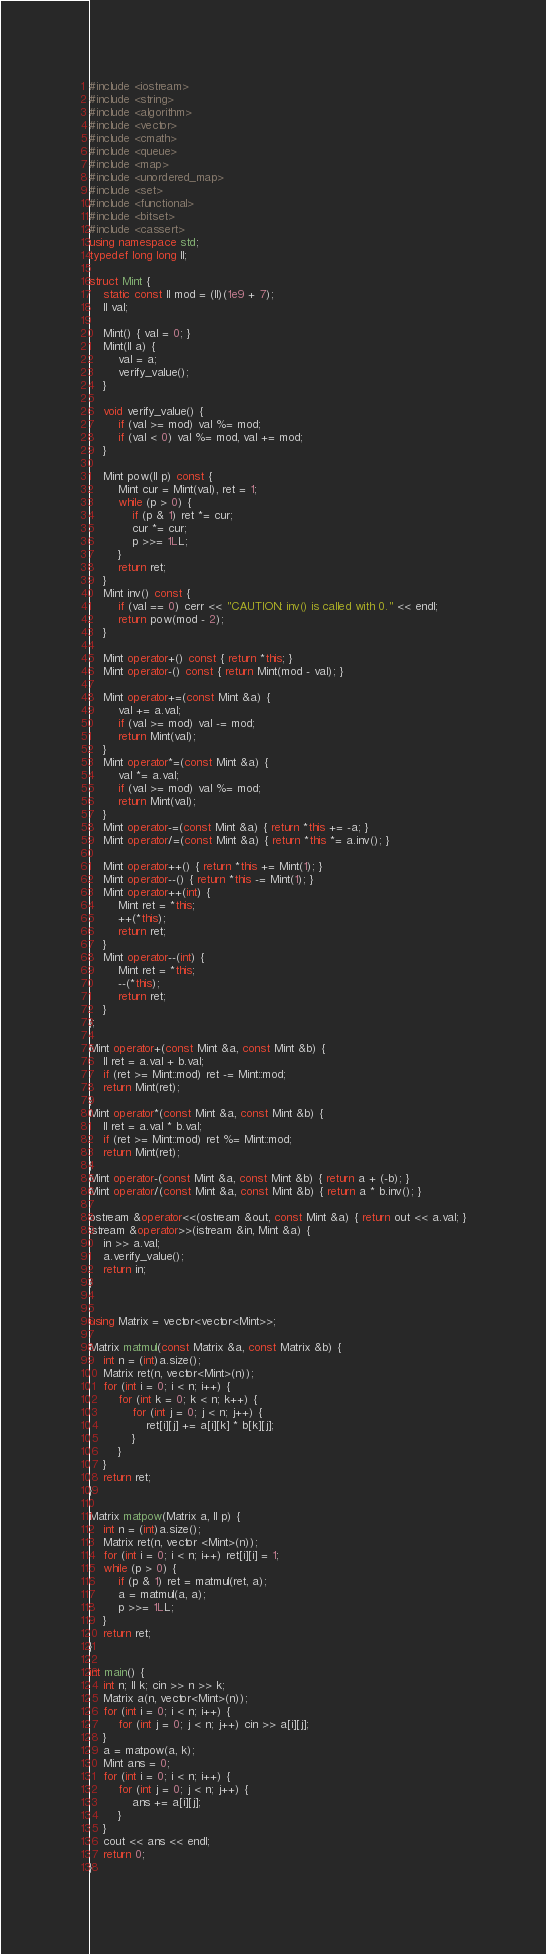Convert code to text. <code><loc_0><loc_0><loc_500><loc_500><_C++_>#include <iostream>
#include <string>
#include <algorithm>
#include <vector>
#include <cmath>
#include <queue>
#include <map>
#include <unordered_map>
#include <set>
#include <functional>
#include <bitset>
#include <cassert>
using namespace std;
typedef long long ll;

struct Mint {
	static const ll mod = (ll)(1e9 + 7);	
	ll val;

	Mint() { val = 0; }
	Mint(ll a) {
		val = a;
		verify_value();
	}

	void verify_value() {
		if (val >= mod) val %= mod;
		if (val < 0) val %= mod, val += mod;
	}

	Mint pow(ll p) const {
		Mint cur = Mint(val), ret = 1;
		while (p > 0) {
			if (p & 1) ret *= cur;
			cur *= cur;
			p >>= 1LL;
		}
		return ret;
	}
	Mint inv() const {
		if (val == 0) cerr << "CAUTION: inv() is called with 0." << endl;
		return pow(mod - 2); 
	}

	Mint operator+() const { return *this; }
	Mint operator-() const { return Mint(mod - val); }

	Mint operator+=(const Mint &a) {
		val += a.val;
		if (val >= mod) val -= mod;
		return Mint(val);
	}
	Mint operator*=(const Mint &a) {
		val *= a.val;
		if (val >= mod) val %= mod;
		return Mint(val);
	}
	Mint operator-=(const Mint &a) { return *this += -a; }
	Mint operator/=(const Mint &a) { return *this *= a.inv(); }

	Mint operator++() { return *this += Mint(1); }
	Mint operator--() { return *this -= Mint(1); }
	Mint operator++(int) {
		Mint ret = *this;
		++(*this);
		return ret;
	}
	Mint operator--(int) {
		Mint ret = *this;
		--(*this);
		return ret;
	}
};

Mint operator+(const Mint &a, const Mint &b) {
	ll ret = a.val + b.val;
	if (ret >= Mint::mod) ret -= Mint::mod;
	return Mint(ret);
}
Mint operator*(const Mint &a, const Mint &b) {
	ll ret = a.val * b.val;
	if (ret >= Mint::mod) ret %= Mint::mod;
	return Mint(ret);
}
Mint operator-(const Mint &a, const Mint &b) { return a + (-b); }
Mint operator/(const Mint &a, const Mint &b) { return a * b.inv(); }

ostream &operator<<(ostream &out, const Mint &a) { return out << a.val; }
istream &operator>>(istream &in, Mint &a) {
	in >> a.val;
	a.verify_value();
	return in;
}


using Matrix = vector<vector<Mint>>;

Matrix matmul(const Matrix &a, const Matrix &b) {
	int n = (int)a.size();
	Matrix ret(n, vector<Mint>(n));
	for (int i = 0; i < n; i++) {
		for (int k = 0; k < n; k++) {
			for (int j = 0; j < n; j++) {
				ret[i][j] += a[i][k] * b[k][j];
			}
		}
	}
	return ret;
}

Matrix matpow(Matrix a, ll p) {
	int n = (int)a.size();
	Matrix ret(n, vector <Mint>(n));
	for (int i = 0; i < n; i++) ret[i][i] = 1;
	while (p > 0) {
		if (p & 1) ret = matmul(ret, a);
		a = matmul(a, a);
		p >>= 1LL;
	}
	return ret;
}

int main() {
	int n; ll k; cin >> n >> k;
	Matrix a(n, vector<Mint>(n));
	for (int i = 0; i < n; i++) {
		for (int j = 0; j < n; j++) cin >> a[i][j];
	}
	a = matpow(a, k);
	Mint ans = 0;
	for (int i = 0; i < n; i++) {
		for (int j = 0; j < n; j++) {
			ans += a[i][j];
		}
	}
	cout << ans << endl;
	return 0;
}</code> 